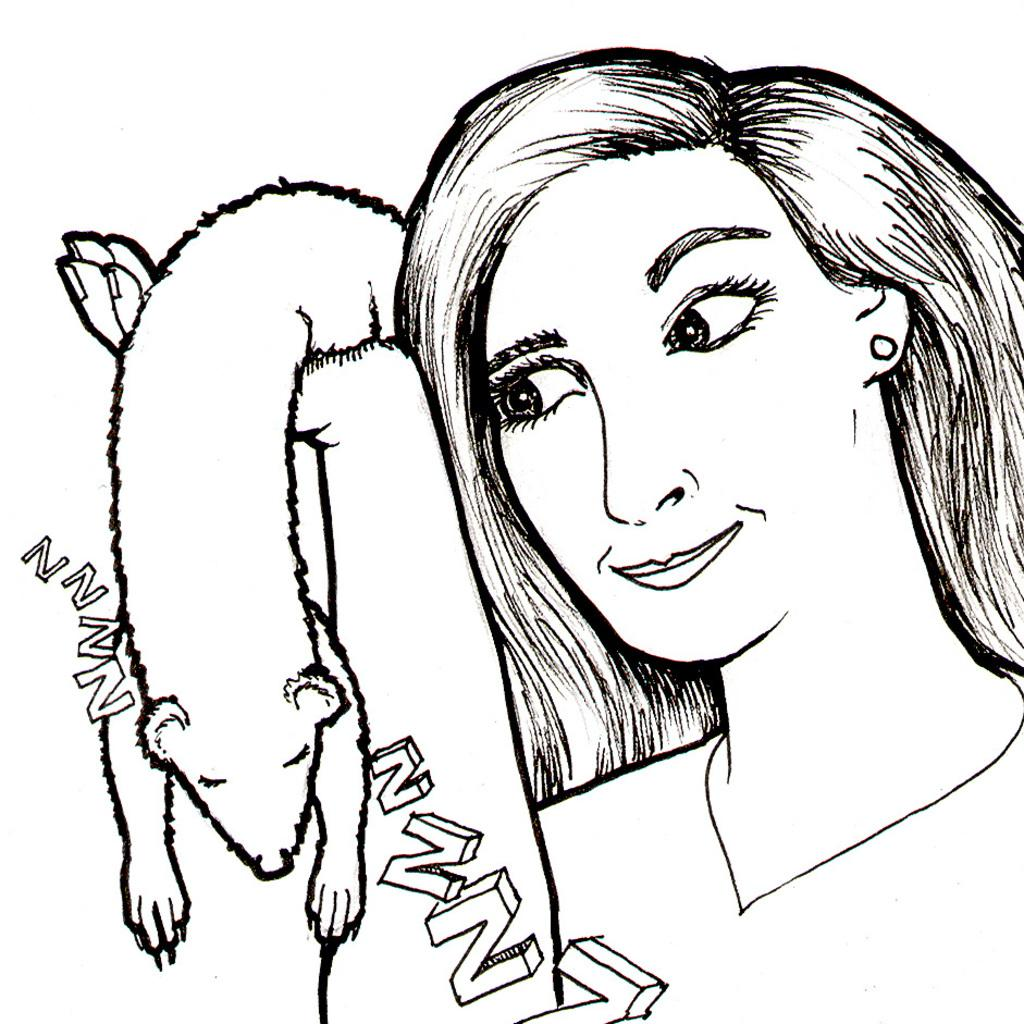What is depicted in the image? There is a sketch of a woman in the image. What is the woman holding in the sketch? The woman is holding an animal in the sketch. What else can be seen in the image besides the sketch of the woman? There is a sketch of an alphabet in the image. What type of punishment is being administered to the woman in the sketch? There is no punishment being administered to the woman in the sketch; she is simply holding an animal. What role does the father play in the sketch? There is no father present in the sketch, as it only features a woman holding an animal and a sketch of an alphabet. 